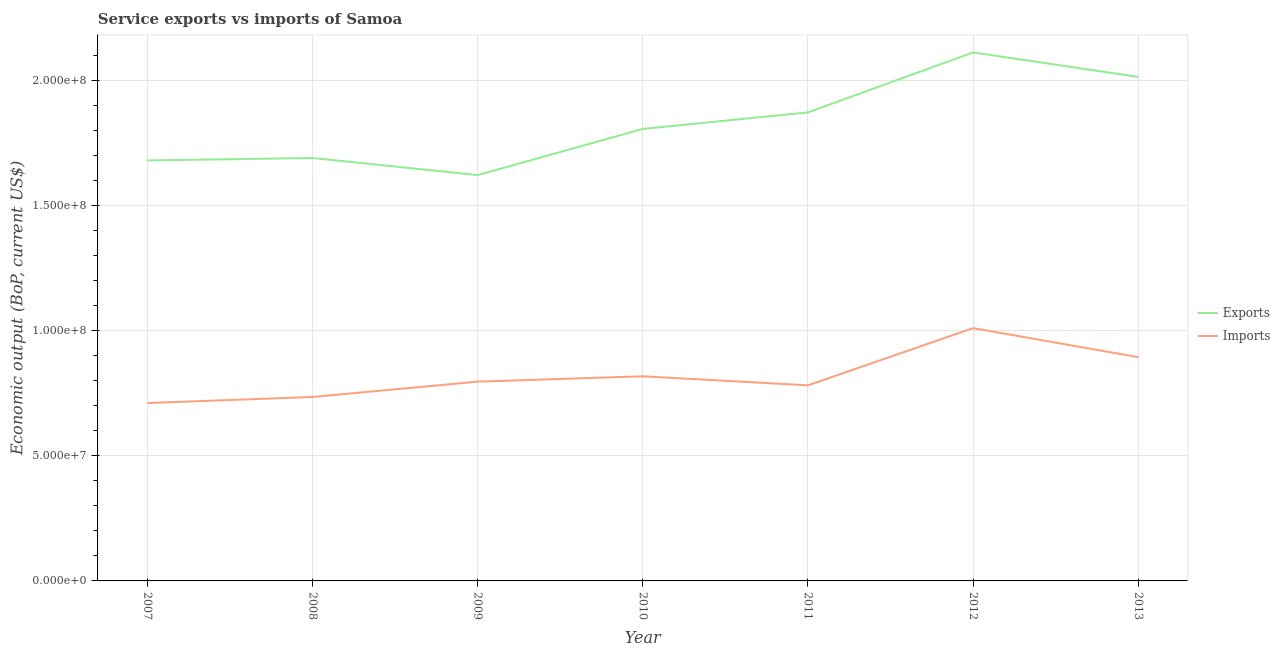What is the amount of service exports in 2013?
Offer a very short reply. 2.01e+08. Across all years, what is the maximum amount of service exports?
Your answer should be compact. 2.11e+08. Across all years, what is the minimum amount of service exports?
Make the answer very short. 1.62e+08. In which year was the amount of service exports minimum?
Keep it short and to the point. 2009. What is the total amount of service imports in the graph?
Ensure brevity in your answer.  5.74e+08. What is the difference between the amount of service exports in 2008 and that in 2011?
Your response must be concise. -1.82e+07. What is the difference between the amount of service exports in 2012 and the amount of service imports in 2008?
Make the answer very short. 1.38e+08. What is the average amount of service imports per year?
Provide a short and direct response. 8.20e+07. In the year 2011, what is the difference between the amount of service exports and amount of service imports?
Your response must be concise. 1.09e+08. In how many years, is the amount of service exports greater than 130000000 US$?
Ensure brevity in your answer.  7. What is the ratio of the amount of service exports in 2009 to that in 2012?
Your answer should be very brief. 0.77. Is the amount of service imports in 2007 less than that in 2009?
Provide a succinct answer. Yes. What is the difference between the highest and the second highest amount of service imports?
Your answer should be very brief. 1.16e+07. What is the difference between the highest and the lowest amount of service imports?
Keep it short and to the point. 2.99e+07. Is the sum of the amount of service exports in 2010 and 2012 greater than the maximum amount of service imports across all years?
Your answer should be very brief. Yes. Is the amount of service exports strictly less than the amount of service imports over the years?
Your answer should be very brief. No. How many lines are there?
Keep it short and to the point. 2. What is the difference between two consecutive major ticks on the Y-axis?
Ensure brevity in your answer.  5.00e+07. Does the graph contain any zero values?
Keep it short and to the point. No. Where does the legend appear in the graph?
Offer a terse response. Center right. How many legend labels are there?
Keep it short and to the point. 2. What is the title of the graph?
Give a very brief answer. Service exports vs imports of Samoa. What is the label or title of the Y-axis?
Offer a very short reply. Economic output (BoP, current US$). What is the Economic output (BoP, current US$) in Exports in 2007?
Provide a short and direct response. 1.68e+08. What is the Economic output (BoP, current US$) of Imports in 2007?
Your answer should be compact. 7.10e+07. What is the Economic output (BoP, current US$) in Exports in 2008?
Provide a succinct answer. 1.69e+08. What is the Economic output (BoP, current US$) in Imports in 2008?
Make the answer very short. 7.35e+07. What is the Economic output (BoP, current US$) of Exports in 2009?
Provide a short and direct response. 1.62e+08. What is the Economic output (BoP, current US$) of Imports in 2009?
Make the answer very short. 7.96e+07. What is the Economic output (BoP, current US$) in Exports in 2010?
Your answer should be very brief. 1.80e+08. What is the Economic output (BoP, current US$) in Imports in 2010?
Offer a terse response. 8.17e+07. What is the Economic output (BoP, current US$) in Exports in 2011?
Your answer should be very brief. 1.87e+08. What is the Economic output (BoP, current US$) of Imports in 2011?
Your answer should be compact. 7.81e+07. What is the Economic output (BoP, current US$) in Exports in 2012?
Your response must be concise. 2.11e+08. What is the Economic output (BoP, current US$) of Imports in 2012?
Provide a short and direct response. 1.01e+08. What is the Economic output (BoP, current US$) of Exports in 2013?
Your response must be concise. 2.01e+08. What is the Economic output (BoP, current US$) of Imports in 2013?
Ensure brevity in your answer.  8.93e+07. Across all years, what is the maximum Economic output (BoP, current US$) in Exports?
Keep it short and to the point. 2.11e+08. Across all years, what is the maximum Economic output (BoP, current US$) in Imports?
Make the answer very short. 1.01e+08. Across all years, what is the minimum Economic output (BoP, current US$) in Exports?
Provide a succinct answer. 1.62e+08. Across all years, what is the minimum Economic output (BoP, current US$) of Imports?
Give a very brief answer. 7.10e+07. What is the total Economic output (BoP, current US$) in Exports in the graph?
Provide a succinct answer. 1.28e+09. What is the total Economic output (BoP, current US$) in Imports in the graph?
Keep it short and to the point. 5.74e+08. What is the difference between the Economic output (BoP, current US$) of Exports in 2007 and that in 2008?
Your answer should be very brief. -9.72e+05. What is the difference between the Economic output (BoP, current US$) in Imports in 2007 and that in 2008?
Keep it short and to the point. -2.42e+06. What is the difference between the Economic output (BoP, current US$) of Exports in 2007 and that in 2009?
Offer a very short reply. 5.85e+06. What is the difference between the Economic output (BoP, current US$) in Imports in 2007 and that in 2009?
Your response must be concise. -8.54e+06. What is the difference between the Economic output (BoP, current US$) of Exports in 2007 and that in 2010?
Your response must be concise. -1.26e+07. What is the difference between the Economic output (BoP, current US$) in Imports in 2007 and that in 2010?
Make the answer very short. -1.07e+07. What is the difference between the Economic output (BoP, current US$) in Exports in 2007 and that in 2011?
Give a very brief answer. -1.92e+07. What is the difference between the Economic output (BoP, current US$) of Imports in 2007 and that in 2011?
Offer a terse response. -7.06e+06. What is the difference between the Economic output (BoP, current US$) of Exports in 2007 and that in 2012?
Your response must be concise. -4.31e+07. What is the difference between the Economic output (BoP, current US$) in Imports in 2007 and that in 2012?
Ensure brevity in your answer.  -2.99e+07. What is the difference between the Economic output (BoP, current US$) of Exports in 2007 and that in 2013?
Your answer should be very brief. -3.33e+07. What is the difference between the Economic output (BoP, current US$) in Imports in 2007 and that in 2013?
Give a very brief answer. -1.83e+07. What is the difference between the Economic output (BoP, current US$) in Exports in 2008 and that in 2009?
Your response must be concise. 6.82e+06. What is the difference between the Economic output (BoP, current US$) of Imports in 2008 and that in 2009?
Give a very brief answer. -6.12e+06. What is the difference between the Economic output (BoP, current US$) of Exports in 2008 and that in 2010?
Give a very brief answer. -1.16e+07. What is the difference between the Economic output (BoP, current US$) of Imports in 2008 and that in 2010?
Ensure brevity in your answer.  -8.26e+06. What is the difference between the Economic output (BoP, current US$) of Exports in 2008 and that in 2011?
Make the answer very short. -1.82e+07. What is the difference between the Economic output (BoP, current US$) of Imports in 2008 and that in 2011?
Your response must be concise. -4.65e+06. What is the difference between the Economic output (BoP, current US$) in Exports in 2008 and that in 2012?
Your answer should be compact. -4.22e+07. What is the difference between the Economic output (BoP, current US$) in Imports in 2008 and that in 2012?
Offer a very short reply. -2.75e+07. What is the difference between the Economic output (BoP, current US$) of Exports in 2008 and that in 2013?
Give a very brief answer. -3.24e+07. What is the difference between the Economic output (BoP, current US$) in Imports in 2008 and that in 2013?
Offer a very short reply. -1.59e+07. What is the difference between the Economic output (BoP, current US$) in Exports in 2009 and that in 2010?
Provide a short and direct response. -1.84e+07. What is the difference between the Economic output (BoP, current US$) in Imports in 2009 and that in 2010?
Make the answer very short. -2.14e+06. What is the difference between the Economic output (BoP, current US$) in Exports in 2009 and that in 2011?
Ensure brevity in your answer.  -2.50e+07. What is the difference between the Economic output (BoP, current US$) of Imports in 2009 and that in 2011?
Provide a succinct answer. 1.47e+06. What is the difference between the Economic output (BoP, current US$) of Exports in 2009 and that in 2012?
Ensure brevity in your answer.  -4.90e+07. What is the difference between the Economic output (BoP, current US$) of Imports in 2009 and that in 2012?
Offer a very short reply. -2.14e+07. What is the difference between the Economic output (BoP, current US$) of Exports in 2009 and that in 2013?
Provide a short and direct response. -3.92e+07. What is the difference between the Economic output (BoP, current US$) of Imports in 2009 and that in 2013?
Your response must be concise. -9.78e+06. What is the difference between the Economic output (BoP, current US$) in Exports in 2010 and that in 2011?
Provide a succinct answer. -6.60e+06. What is the difference between the Economic output (BoP, current US$) of Imports in 2010 and that in 2011?
Your answer should be compact. 3.62e+06. What is the difference between the Economic output (BoP, current US$) of Exports in 2010 and that in 2012?
Make the answer very short. -3.06e+07. What is the difference between the Economic output (BoP, current US$) in Imports in 2010 and that in 2012?
Your response must be concise. -1.92e+07. What is the difference between the Economic output (BoP, current US$) of Exports in 2010 and that in 2013?
Your answer should be very brief. -2.08e+07. What is the difference between the Economic output (BoP, current US$) in Imports in 2010 and that in 2013?
Offer a terse response. -7.63e+06. What is the difference between the Economic output (BoP, current US$) of Exports in 2011 and that in 2012?
Make the answer very short. -2.40e+07. What is the difference between the Economic output (BoP, current US$) of Imports in 2011 and that in 2012?
Ensure brevity in your answer.  -2.29e+07. What is the difference between the Economic output (BoP, current US$) in Exports in 2011 and that in 2013?
Offer a terse response. -1.42e+07. What is the difference between the Economic output (BoP, current US$) in Imports in 2011 and that in 2013?
Ensure brevity in your answer.  -1.12e+07. What is the difference between the Economic output (BoP, current US$) in Exports in 2012 and that in 2013?
Give a very brief answer. 9.79e+06. What is the difference between the Economic output (BoP, current US$) of Imports in 2012 and that in 2013?
Offer a very short reply. 1.16e+07. What is the difference between the Economic output (BoP, current US$) in Exports in 2007 and the Economic output (BoP, current US$) in Imports in 2008?
Offer a very short reply. 9.45e+07. What is the difference between the Economic output (BoP, current US$) of Exports in 2007 and the Economic output (BoP, current US$) of Imports in 2009?
Your answer should be very brief. 8.83e+07. What is the difference between the Economic output (BoP, current US$) in Exports in 2007 and the Economic output (BoP, current US$) in Imports in 2010?
Your answer should be very brief. 8.62e+07. What is the difference between the Economic output (BoP, current US$) in Exports in 2007 and the Economic output (BoP, current US$) in Imports in 2011?
Make the answer very short. 8.98e+07. What is the difference between the Economic output (BoP, current US$) in Exports in 2007 and the Economic output (BoP, current US$) in Imports in 2012?
Your response must be concise. 6.70e+07. What is the difference between the Economic output (BoP, current US$) in Exports in 2007 and the Economic output (BoP, current US$) in Imports in 2013?
Your response must be concise. 7.86e+07. What is the difference between the Economic output (BoP, current US$) of Exports in 2008 and the Economic output (BoP, current US$) of Imports in 2009?
Keep it short and to the point. 8.93e+07. What is the difference between the Economic output (BoP, current US$) of Exports in 2008 and the Economic output (BoP, current US$) of Imports in 2010?
Keep it short and to the point. 8.72e+07. What is the difference between the Economic output (BoP, current US$) of Exports in 2008 and the Economic output (BoP, current US$) of Imports in 2011?
Offer a terse response. 9.08e+07. What is the difference between the Economic output (BoP, current US$) of Exports in 2008 and the Economic output (BoP, current US$) of Imports in 2012?
Provide a short and direct response. 6.79e+07. What is the difference between the Economic output (BoP, current US$) of Exports in 2008 and the Economic output (BoP, current US$) of Imports in 2013?
Offer a very short reply. 7.95e+07. What is the difference between the Economic output (BoP, current US$) in Exports in 2009 and the Economic output (BoP, current US$) in Imports in 2010?
Provide a succinct answer. 8.03e+07. What is the difference between the Economic output (BoP, current US$) of Exports in 2009 and the Economic output (BoP, current US$) of Imports in 2011?
Your answer should be compact. 8.40e+07. What is the difference between the Economic output (BoP, current US$) in Exports in 2009 and the Economic output (BoP, current US$) in Imports in 2012?
Offer a very short reply. 6.11e+07. What is the difference between the Economic output (BoP, current US$) in Exports in 2009 and the Economic output (BoP, current US$) in Imports in 2013?
Ensure brevity in your answer.  7.27e+07. What is the difference between the Economic output (BoP, current US$) in Exports in 2010 and the Economic output (BoP, current US$) in Imports in 2011?
Offer a terse response. 1.02e+08. What is the difference between the Economic output (BoP, current US$) of Exports in 2010 and the Economic output (BoP, current US$) of Imports in 2012?
Keep it short and to the point. 7.95e+07. What is the difference between the Economic output (BoP, current US$) in Exports in 2010 and the Economic output (BoP, current US$) in Imports in 2013?
Make the answer very short. 9.11e+07. What is the difference between the Economic output (BoP, current US$) of Exports in 2011 and the Economic output (BoP, current US$) of Imports in 2012?
Keep it short and to the point. 8.61e+07. What is the difference between the Economic output (BoP, current US$) of Exports in 2011 and the Economic output (BoP, current US$) of Imports in 2013?
Your response must be concise. 9.77e+07. What is the difference between the Economic output (BoP, current US$) in Exports in 2012 and the Economic output (BoP, current US$) in Imports in 2013?
Offer a very short reply. 1.22e+08. What is the average Economic output (BoP, current US$) in Exports per year?
Your answer should be compact. 1.83e+08. What is the average Economic output (BoP, current US$) of Imports per year?
Keep it short and to the point. 8.20e+07. In the year 2007, what is the difference between the Economic output (BoP, current US$) in Exports and Economic output (BoP, current US$) in Imports?
Provide a succinct answer. 9.69e+07. In the year 2008, what is the difference between the Economic output (BoP, current US$) in Exports and Economic output (BoP, current US$) in Imports?
Provide a succinct answer. 9.54e+07. In the year 2009, what is the difference between the Economic output (BoP, current US$) in Exports and Economic output (BoP, current US$) in Imports?
Provide a succinct answer. 8.25e+07. In the year 2010, what is the difference between the Economic output (BoP, current US$) in Exports and Economic output (BoP, current US$) in Imports?
Your answer should be compact. 9.88e+07. In the year 2011, what is the difference between the Economic output (BoP, current US$) of Exports and Economic output (BoP, current US$) of Imports?
Offer a very short reply. 1.09e+08. In the year 2012, what is the difference between the Economic output (BoP, current US$) in Exports and Economic output (BoP, current US$) in Imports?
Provide a short and direct response. 1.10e+08. In the year 2013, what is the difference between the Economic output (BoP, current US$) of Exports and Economic output (BoP, current US$) of Imports?
Keep it short and to the point. 1.12e+08. What is the ratio of the Economic output (BoP, current US$) of Exports in 2007 to that in 2008?
Ensure brevity in your answer.  0.99. What is the ratio of the Economic output (BoP, current US$) of Imports in 2007 to that in 2008?
Provide a short and direct response. 0.97. What is the ratio of the Economic output (BoP, current US$) of Exports in 2007 to that in 2009?
Make the answer very short. 1.04. What is the ratio of the Economic output (BoP, current US$) of Imports in 2007 to that in 2009?
Ensure brevity in your answer.  0.89. What is the ratio of the Economic output (BoP, current US$) of Exports in 2007 to that in 2010?
Make the answer very short. 0.93. What is the ratio of the Economic output (BoP, current US$) in Imports in 2007 to that in 2010?
Offer a very short reply. 0.87. What is the ratio of the Economic output (BoP, current US$) of Exports in 2007 to that in 2011?
Offer a terse response. 0.9. What is the ratio of the Economic output (BoP, current US$) in Imports in 2007 to that in 2011?
Your answer should be very brief. 0.91. What is the ratio of the Economic output (BoP, current US$) in Exports in 2007 to that in 2012?
Offer a terse response. 0.8. What is the ratio of the Economic output (BoP, current US$) of Imports in 2007 to that in 2012?
Provide a succinct answer. 0.7. What is the ratio of the Economic output (BoP, current US$) in Exports in 2007 to that in 2013?
Your answer should be compact. 0.83. What is the ratio of the Economic output (BoP, current US$) in Imports in 2007 to that in 2013?
Make the answer very short. 0.8. What is the ratio of the Economic output (BoP, current US$) of Exports in 2008 to that in 2009?
Provide a succinct answer. 1.04. What is the ratio of the Economic output (BoP, current US$) in Exports in 2008 to that in 2010?
Your response must be concise. 0.94. What is the ratio of the Economic output (BoP, current US$) of Imports in 2008 to that in 2010?
Your answer should be compact. 0.9. What is the ratio of the Economic output (BoP, current US$) in Exports in 2008 to that in 2011?
Keep it short and to the point. 0.9. What is the ratio of the Economic output (BoP, current US$) of Imports in 2008 to that in 2011?
Provide a succinct answer. 0.94. What is the ratio of the Economic output (BoP, current US$) of Exports in 2008 to that in 2012?
Ensure brevity in your answer.  0.8. What is the ratio of the Economic output (BoP, current US$) of Imports in 2008 to that in 2012?
Provide a succinct answer. 0.73. What is the ratio of the Economic output (BoP, current US$) of Exports in 2008 to that in 2013?
Ensure brevity in your answer.  0.84. What is the ratio of the Economic output (BoP, current US$) in Imports in 2008 to that in 2013?
Give a very brief answer. 0.82. What is the ratio of the Economic output (BoP, current US$) of Exports in 2009 to that in 2010?
Keep it short and to the point. 0.9. What is the ratio of the Economic output (BoP, current US$) in Imports in 2009 to that in 2010?
Keep it short and to the point. 0.97. What is the ratio of the Economic output (BoP, current US$) of Exports in 2009 to that in 2011?
Offer a very short reply. 0.87. What is the ratio of the Economic output (BoP, current US$) of Imports in 2009 to that in 2011?
Give a very brief answer. 1.02. What is the ratio of the Economic output (BoP, current US$) in Exports in 2009 to that in 2012?
Your answer should be compact. 0.77. What is the ratio of the Economic output (BoP, current US$) of Imports in 2009 to that in 2012?
Your answer should be very brief. 0.79. What is the ratio of the Economic output (BoP, current US$) of Exports in 2009 to that in 2013?
Make the answer very short. 0.81. What is the ratio of the Economic output (BoP, current US$) of Imports in 2009 to that in 2013?
Make the answer very short. 0.89. What is the ratio of the Economic output (BoP, current US$) in Exports in 2010 to that in 2011?
Provide a short and direct response. 0.96. What is the ratio of the Economic output (BoP, current US$) in Imports in 2010 to that in 2011?
Your response must be concise. 1.05. What is the ratio of the Economic output (BoP, current US$) of Exports in 2010 to that in 2012?
Your response must be concise. 0.86. What is the ratio of the Economic output (BoP, current US$) of Imports in 2010 to that in 2012?
Provide a short and direct response. 0.81. What is the ratio of the Economic output (BoP, current US$) of Exports in 2010 to that in 2013?
Your response must be concise. 0.9. What is the ratio of the Economic output (BoP, current US$) in Imports in 2010 to that in 2013?
Your answer should be compact. 0.91. What is the ratio of the Economic output (BoP, current US$) in Exports in 2011 to that in 2012?
Give a very brief answer. 0.89. What is the ratio of the Economic output (BoP, current US$) of Imports in 2011 to that in 2012?
Ensure brevity in your answer.  0.77. What is the ratio of the Economic output (BoP, current US$) in Exports in 2011 to that in 2013?
Provide a succinct answer. 0.93. What is the ratio of the Economic output (BoP, current US$) in Imports in 2011 to that in 2013?
Offer a very short reply. 0.87. What is the ratio of the Economic output (BoP, current US$) of Exports in 2012 to that in 2013?
Give a very brief answer. 1.05. What is the ratio of the Economic output (BoP, current US$) in Imports in 2012 to that in 2013?
Keep it short and to the point. 1.13. What is the difference between the highest and the second highest Economic output (BoP, current US$) in Exports?
Keep it short and to the point. 9.79e+06. What is the difference between the highest and the second highest Economic output (BoP, current US$) of Imports?
Offer a terse response. 1.16e+07. What is the difference between the highest and the lowest Economic output (BoP, current US$) of Exports?
Ensure brevity in your answer.  4.90e+07. What is the difference between the highest and the lowest Economic output (BoP, current US$) in Imports?
Give a very brief answer. 2.99e+07. 